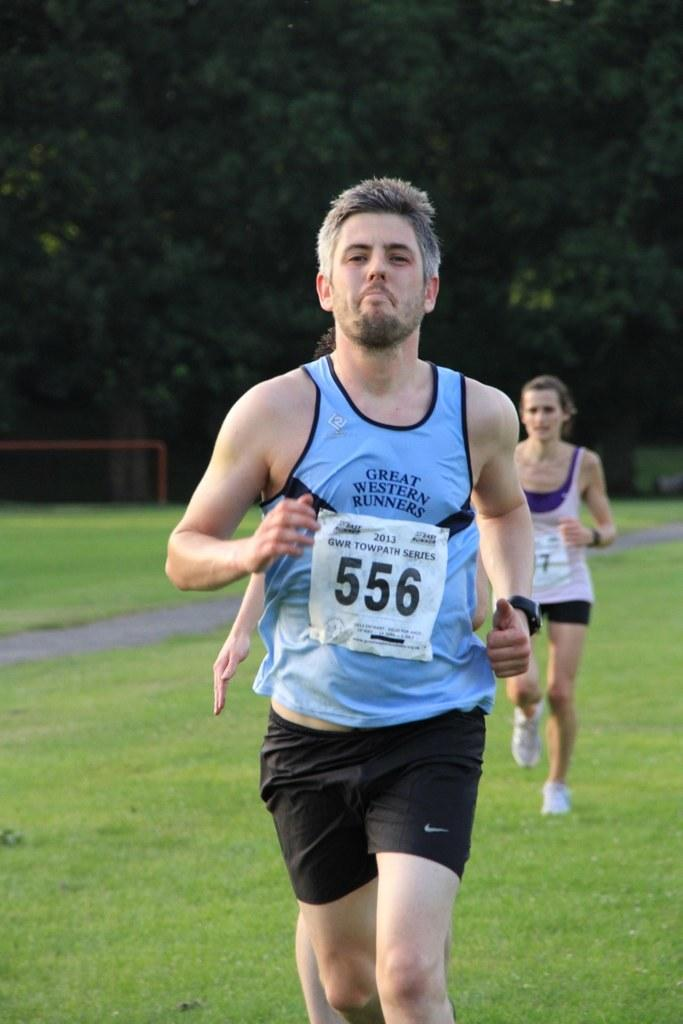<image>
Summarize the visual content of the image. Racer 556 is in front of at least two others on a grass field. 